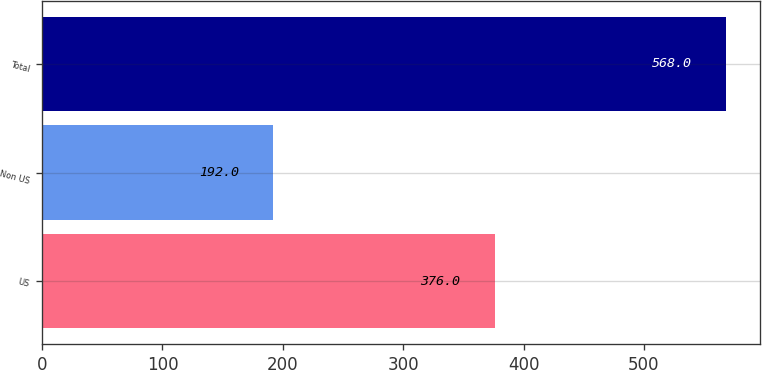<chart> <loc_0><loc_0><loc_500><loc_500><bar_chart><fcel>US<fcel>Non US<fcel>Total<nl><fcel>376<fcel>192<fcel>568<nl></chart> 